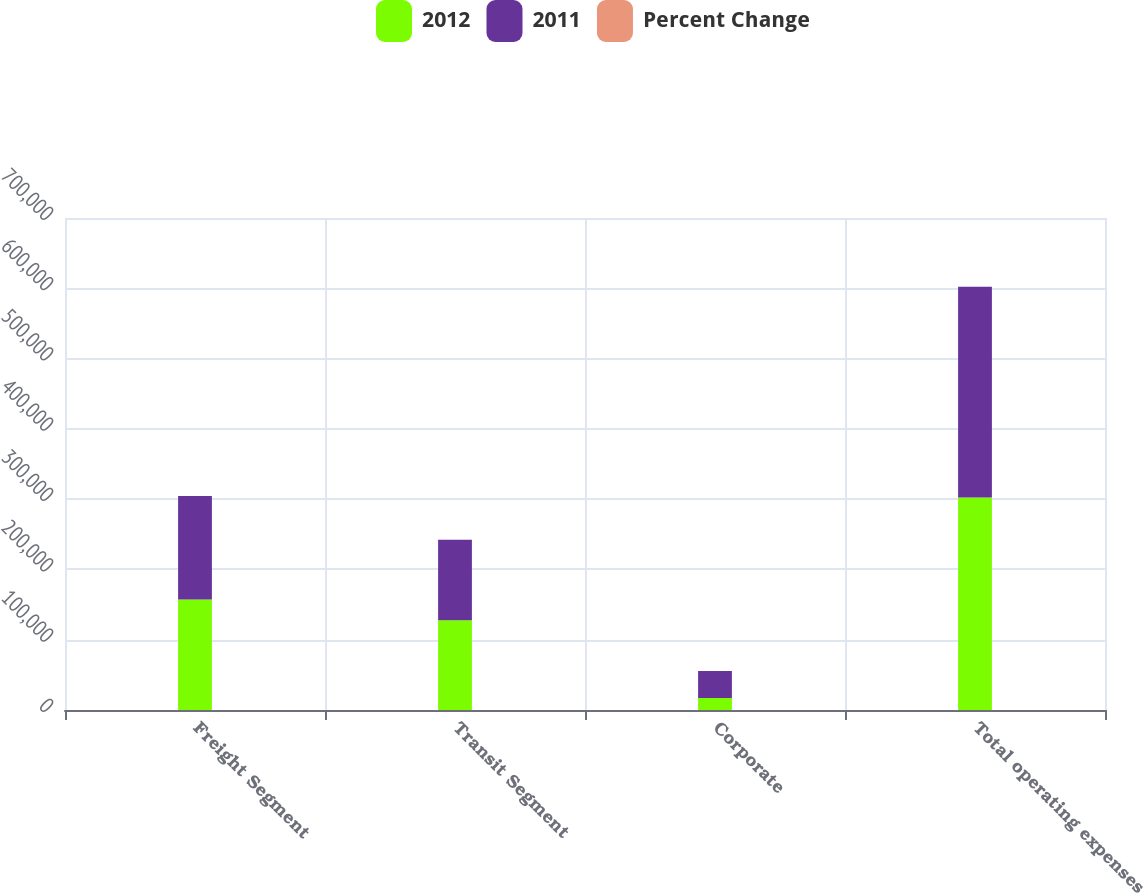<chart> <loc_0><loc_0><loc_500><loc_500><stacked_bar_chart><ecel><fcel>Freight Segment<fcel>Transit Segment<fcel>Corporate<fcel>Total operating expenses<nl><fcel>2012<fcel>157320<fcel>127759<fcel>17209<fcel>302288<nl><fcel>2011<fcel>146992<fcel>114390<fcel>38341<fcel>299723<nl><fcel>Percent Change<fcel>7<fcel>11.7<fcel>55.1<fcel>0.9<nl></chart> 